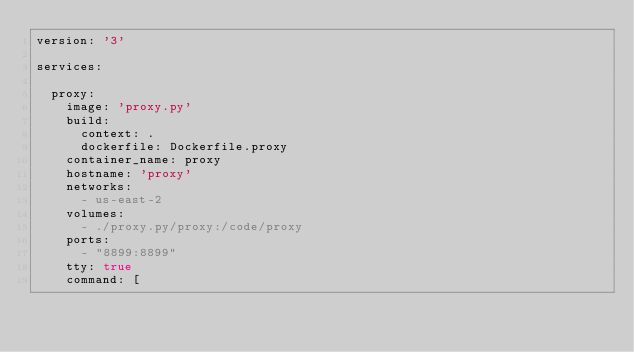<code> <loc_0><loc_0><loc_500><loc_500><_YAML_>version: '3'

services:

  proxy:
    image: 'proxy.py'
    build:
      context: .
      dockerfile: Dockerfile.proxy
    container_name: proxy
    hostname: 'proxy'
    networks:
      - us-east-2
    volumes:
      - ./proxy.py/proxy:/code/proxy
    ports:
      - "8899:8899"
    tty: true
    command: [</code> 